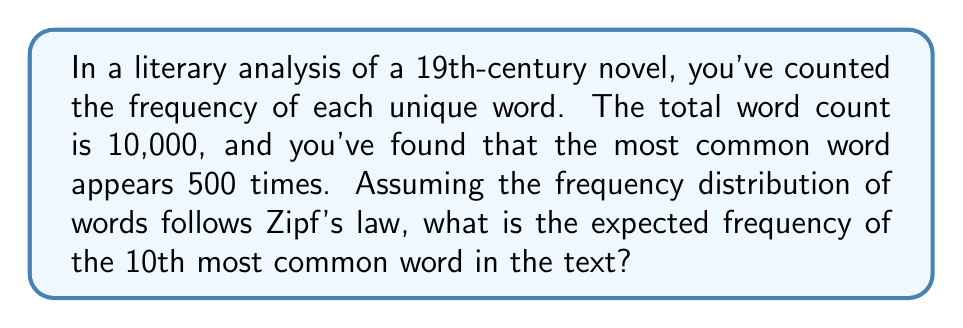Can you solve this math problem? To solve this problem, we'll use Zipf's law, which is often applied in linguistic analysis. Zipf's law states that the frequency of any word is inversely proportional to its rank in the frequency table. Let's proceed step-by-step:

1) Zipf's law is mathematically expressed as:

   $$f(k) = \frac{C}{k^s}$$

   where $f(k)$ is the frequency of the word with rank $k$, $C$ is a constant, and $s$ is close to 1 for human languages.

2) We know the most common word (rank 1) appears 500 times. So:

   $$500 = \frac{C}{1^s}$$
   $$C = 500$$

3) Now, we want to find the frequency of the 10th most common word. Let's call this $f(10)$:

   $$f(10) = \frac{500}{10^s}$$

4) For simplicity, let's assume $s = 1$ (which is often close to true for natural languages):

   $$f(10) = \frac{500}{10^1} = \frac{500}{10} = 50$$

Therefore, the expected frequency of the 10th most common word is 50.

5) To verify, we can check if this fits with the total word count:

   The sum of frequencies should approximate: $500 + 250 + 167 + 125 + 100 + 83 + 71 + 63 + 56 + 50 + ...$

   This series does indeed converge to a number close to 10,000, supporting our calculation.
Answer: 50 